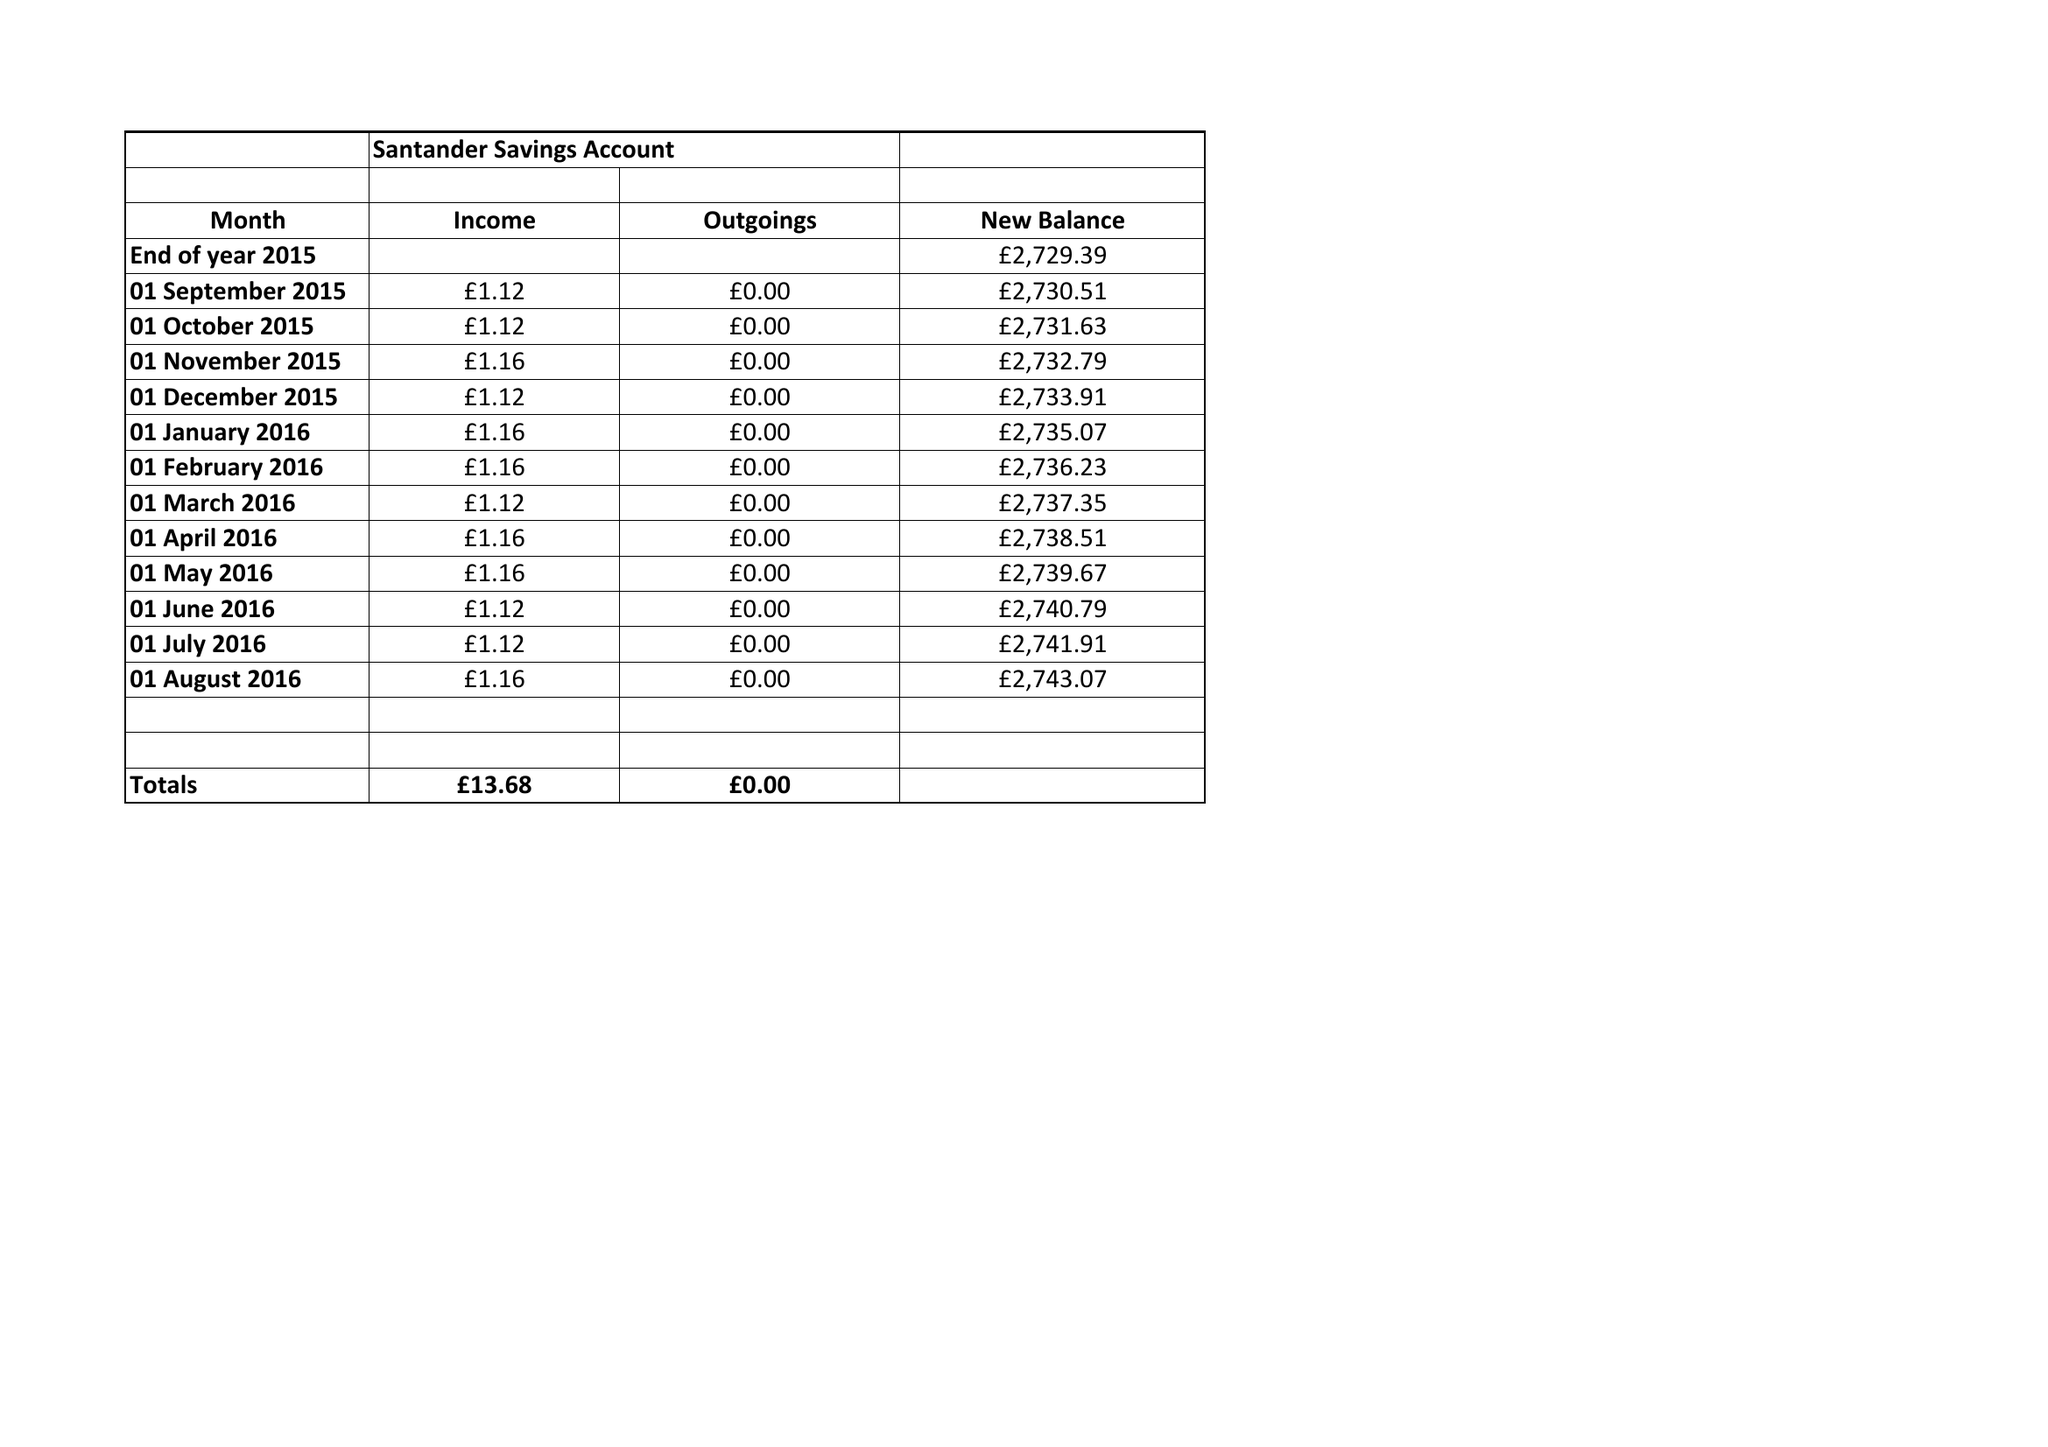What is the value for the address__post_town?
Answer the question using a single word or phrase. None 